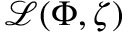Convert formula to latex. <formula><loc_0><loc_0><loc_500><loc_500>{ \mathcal { L } } ( \Phi , \zeta )</formula> 